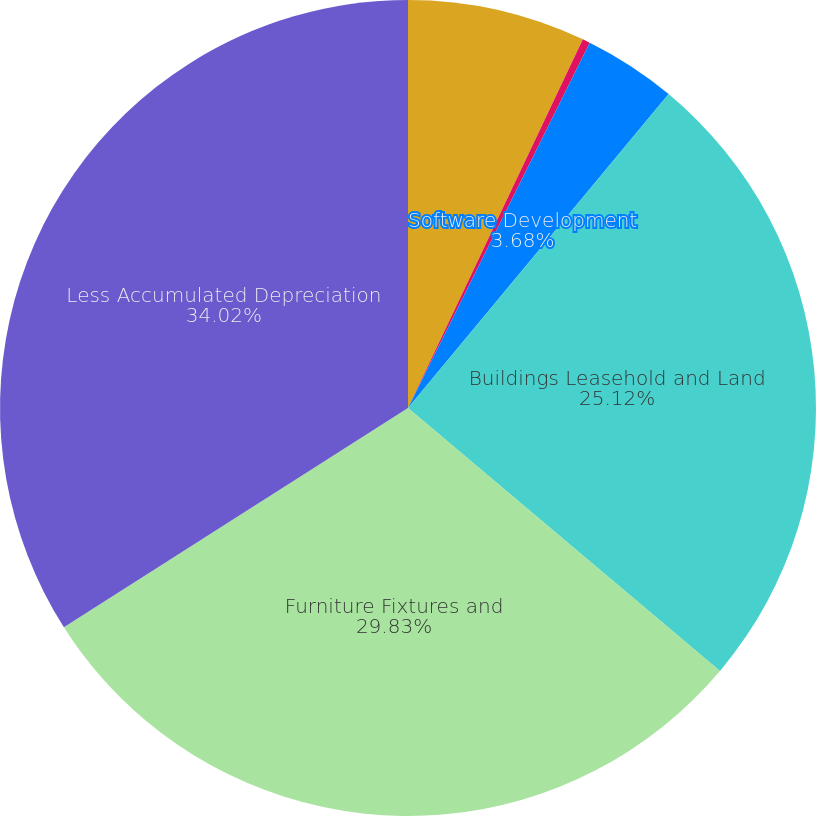<chart> <loc_0><loc_0><loc_500><loc_500><pie_chart><fcel>Land<fcel>Construction in Process<fcel>Software Development<fcel>Buildings Leasehold and Land<fcel>Furniture Fixtures and<fcel>Less Accumulated Depreciation<nl><fcel>7.05%<fcel>0.3%<fcel>3.68%<fcel>25.12%<fcel>29.83%<fcel>34.03%<nl></chart> 